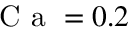<formula> <loc_0><loc_0><loc_500><loc_500>C a = 0 . 2</formula> 